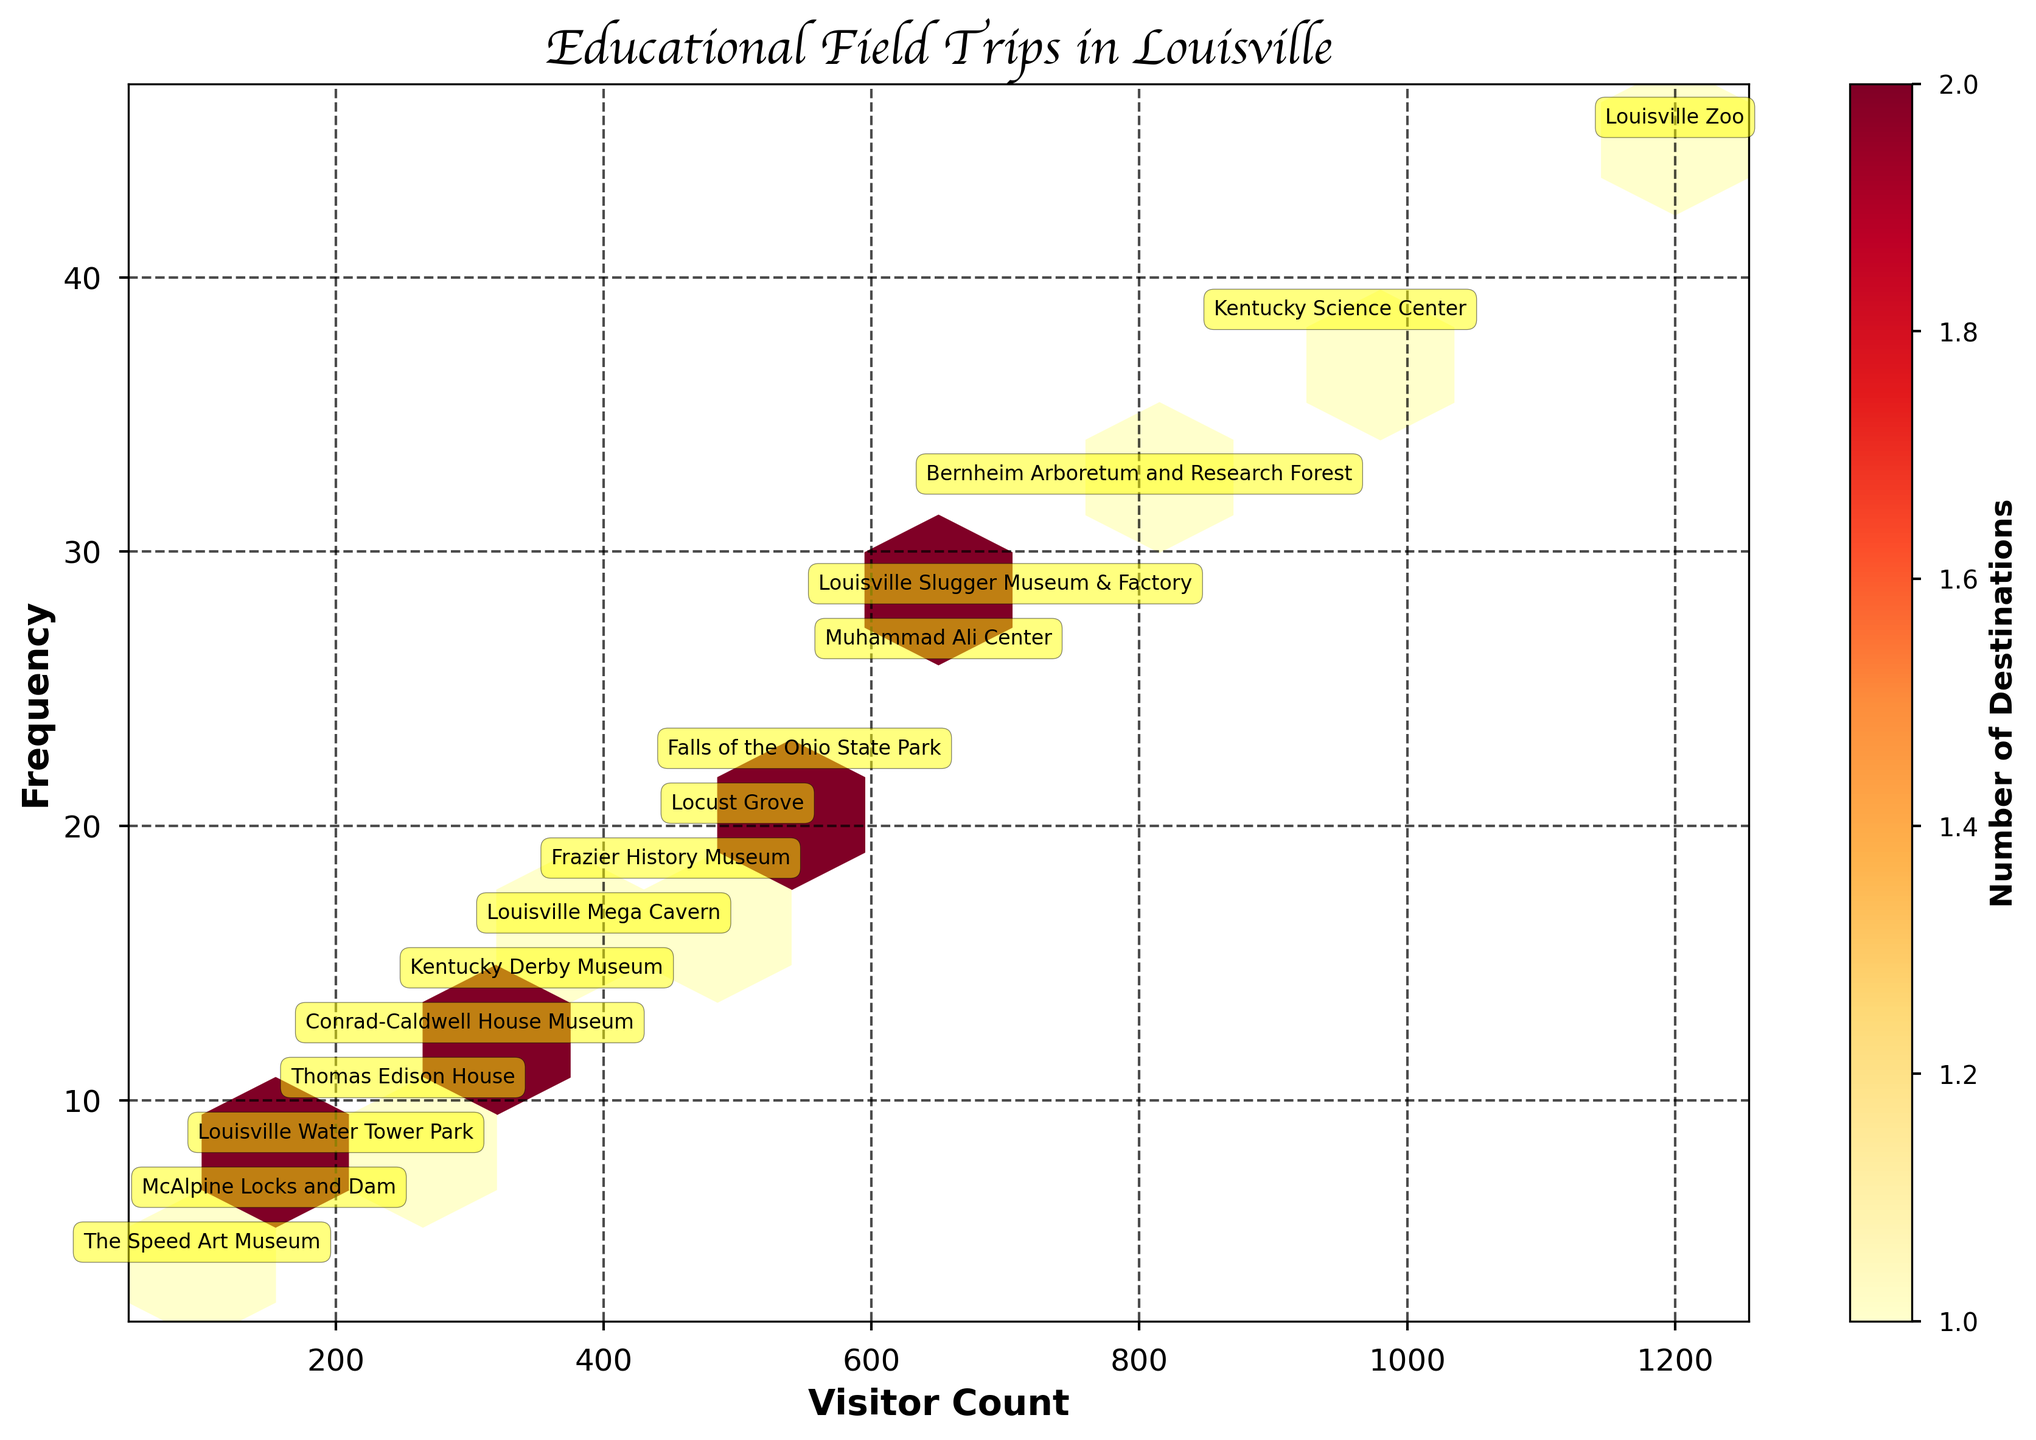What is the title of the plot? The title is prominently displayed at the top of the plot. It reads "Educational Field Trips in Louisville".
Answer: Educational Field Trips in Louisville What does the color bar represent? The color bar on the right side of the plot is labeled "Number of Destinations". It indicates how many destinations fall within each hexagonal cell of the plot.
Answer: Number of Destinations How many destinations have a visitor count greater than 500 and a frequency greater than 20? By observing the plot and the annotated labels within the hexbin cells, we can count that there are four destinations that meet this criterion: Louisville Zoo, Kentucky Science Center, Bernheim Arboretum and Research Forest, and Louisville Slugger Museum & Factory.
Answer: 4 Which destination has the highest visitor count and what is its frequency? The Louisville Zoo is annotated at the topmost right cell with the highest visitor count of 1200 and a corresponding frequency of 45 visits.
Answer: Louisville Zoo, 45 What is the relationship between visitor count and frequency for most destinations? Most destinations appear to have a positive linear relationship between visitor count and frequency, meaning that as the visitor count increases, the frequency of trips also tends to increase.
Answer: Positive linear relationship How many hexagons have more than one destination inside them according to the color gradient? By viewing the color gradient of the hexagonal cells, it appears there are a few lighter hexagons, particularly where the visitor counts range from approximately 400 to 700 and frequencies from about 16 to 28. These lighter hexagons indicate more than one destination is present within them.
Answer: A few (exact number to visually inspect) Which destination appears in the bottom-left corner of the plot, indicating the lowest visitor count and frequency? The Speed Art Museum has the lowest values, located in the bottom-left corner with a visitor count of 100 and a frequency of 4.
Answer: The Speed Art Museum Compare the frequency of Louisville Slugger Museum & Factory and Muhammad Ali Center. Which one has a higher frequency and by how much? Louisville Slugger Museum & Factory has a frequency of 28, whereas Muhammad Ali Center has a frequency of 26. The difference in frequency is 28 - 26 = 2.
Answer: Louisville Slugger Museum & Factory by 2 Is there any destination whose frequency is higher than its visitor count? By reviewing the plot annotations, none of the destinations have a frequency higher than their visitor count. Typically, frequency numbers are lower than visitor counts.
Answer: No What is the sum of visitor counts for destinations with a frequency of more than 10 but less than 20? The destinations meeting this frequency criterion are: Frazier History Museum (450), Louisville Mega Cavern (400), and Kentucky Derby Museum (350). Summing their visitor counts results in 450 + 400 + 350 = 1200.
Answer: 1200 